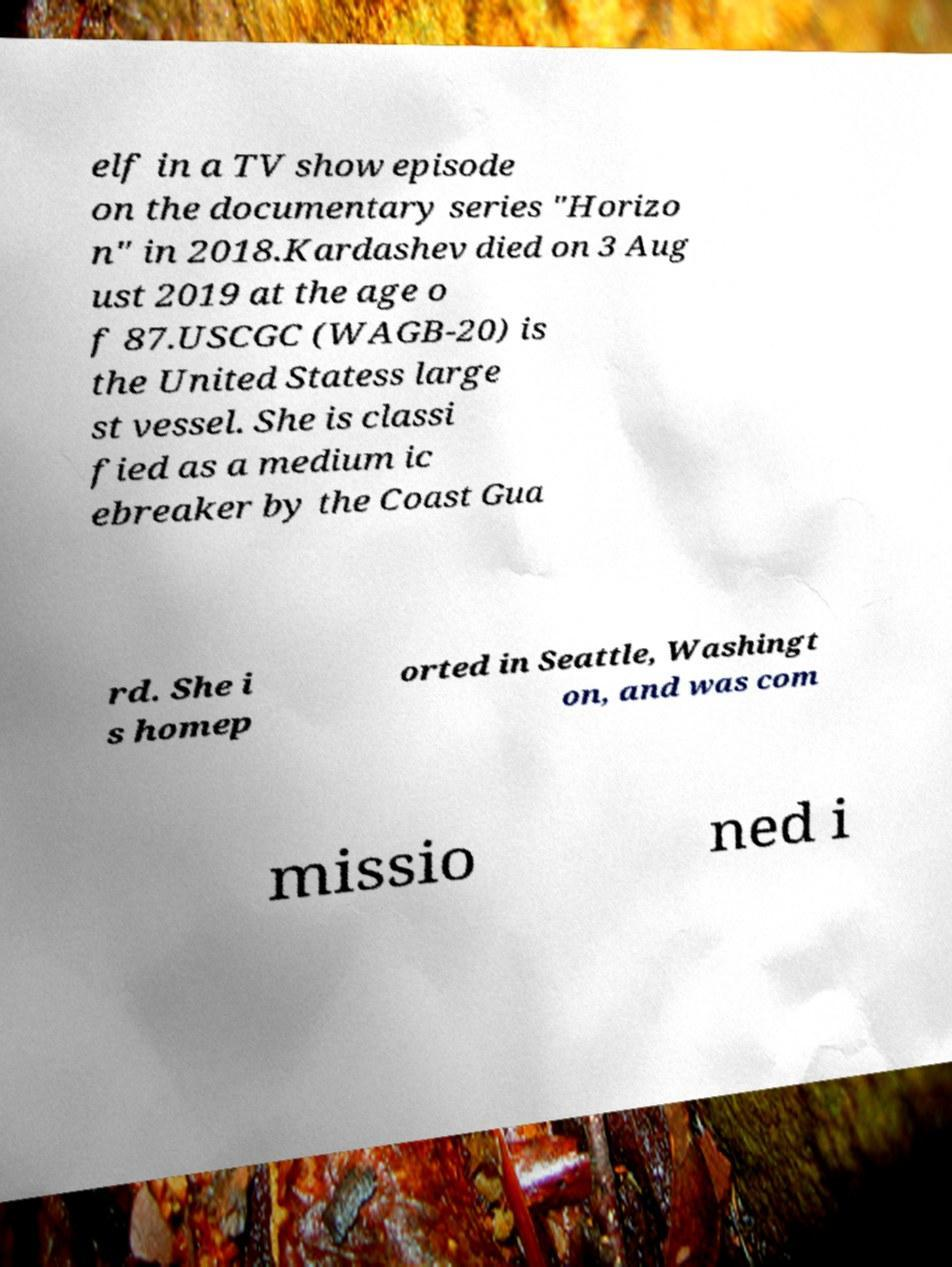I need the written content from this picture converted into text. Can you do that? elf in a TV show episode on the documentary series "Horizo n" in 2018.Kardashev died on 3 Aug ust 2019 at the age o f 87.USCGC (WAGB-20) is the United Statess large st vessel. She is classi fied as a medium ic ebreaker by the Coast Gua rd. She i s homep orted in Seattle, Washingt on, and was com missio ned i 